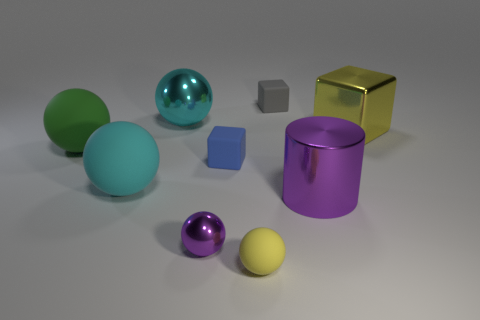What is the color of the other metal object that is the same shape as the tiny metallic object?
Provide a short and direct response. Cyan. What number of blue objects are the same shape as the big yellow thing?
Your answer should be very brief. 1. There is a object that is the same color as the metallic cylinder; what material is it?
Ensure brevity in your answer.  Metal. How many cyan spheres are there?
Keep it short and to the point. 2. Are there any big yellow things that have the same material as the purple cylinder?
Your response must be concise. Yes. There is a metallic cube that is the same color as the tiny matte ball; what size is it?
Your answer should be compact. Large. There is a purple metal object behind the tiny purple metallic ball; is its size the same as the cyan ball that is in front of the big block?
Your response must be concise. Yes. How big is the purple metal object right of the blue object?
Keep it short and to the point. Large. Are there any large metal cubes of the same color as the small matte ball?
Ensure brevity in your answer.  Yes. Is there a matte cube behind the yellow object on the right side of the big purple metallic cylinder?
Provide a short and direct response. Yes. 